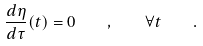Convert formula to latex. <formula><loc_0><loc_0><loc_500><loc_500>\frac { d \eta } { d \tau } ( t ) = 0 \quad , \quad \forall t \quad .</formula> 